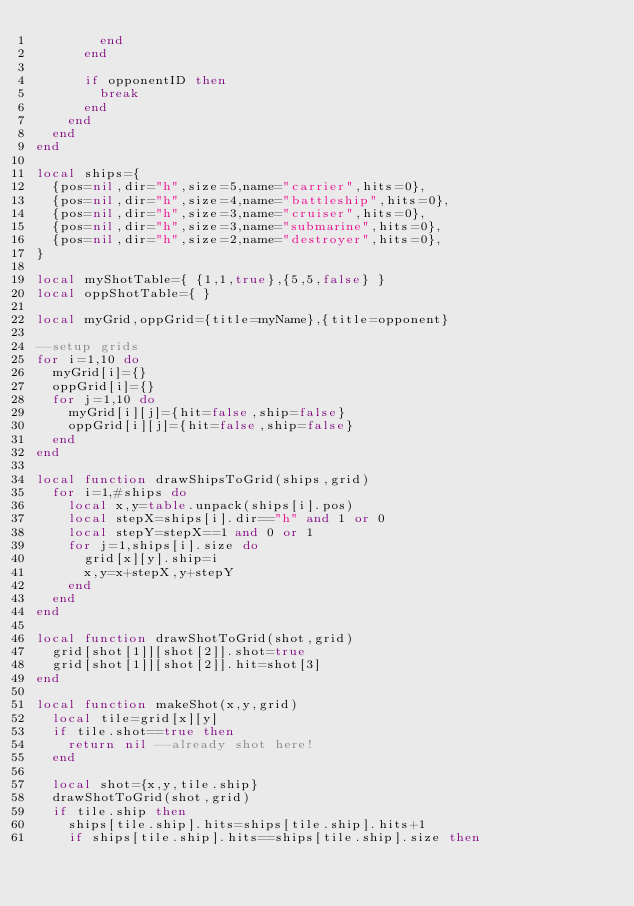<code> <loc_0><loc_0><loc_500><loc_500><_Lua_>        end
      end
     
      if opponentID then
        break
      end
    end
  end
end
 
local ships={
  {pos=nil,dir="h",size=5,name="carrier",hits=0},
  {pos=nil,dir="h",size=4,name="battleship",hits=0},
  {pos=nil,dir="h",size=3,name="cruiser",hits=0},
  {pos=nil,dir="h",size=3,name="submarine",hits=0},
  {pos=nil,dir="h",size=2,name="destroyer",hits=0},
}
 
local myShotTable={ {1,1,true},{5,5,false} }
local oppShotTable={ }
 
local myGrid,oppGrid={title=myName},{title=opponent}
 
--setup grids
for i=1,10 do
  myGrid[i]={}
  oppGrid[i]={}
  for j=1,10 do
    myGrid[i][j]={hit=false,ship=false}
    oppGrid[i][j]={hit=false,ship=false}
  end
end
 
local function drawShipsToGrid(ships,grid)  
  for i=1,#ships do
    local x,y=table.unpack(ships[i].pos)
    local stepX=ships[i].dir=="h" and 1 or 0
    local stepY=stepX==1 and 0 or 1
    for j=1,ships[i].size do
      grid[x][y].ship=i
      x,y=x+stepX,y+stepY
    end
  end
end
 
local function drawShotToGrid(shot,grid)
  grid[shot[1]][shot[2]].shot=true
  grid[shot[1]][shot[2]].hit=shot[3]  
end
 
local function makeShot(x,y,grid)
  local tile=grid[x][y]
  if tile.shot==true then
    return nil --already shot here!
  end  
 
  local shot={x,y,tile.ship}
  drawShotToGrid(shot,grid)
  if tile.ship then
    ships[tile.ship].hits=ships[tile.ship].hits+1
    if ships[tile.ship].hits==ships[tile.ship].size then</code> 